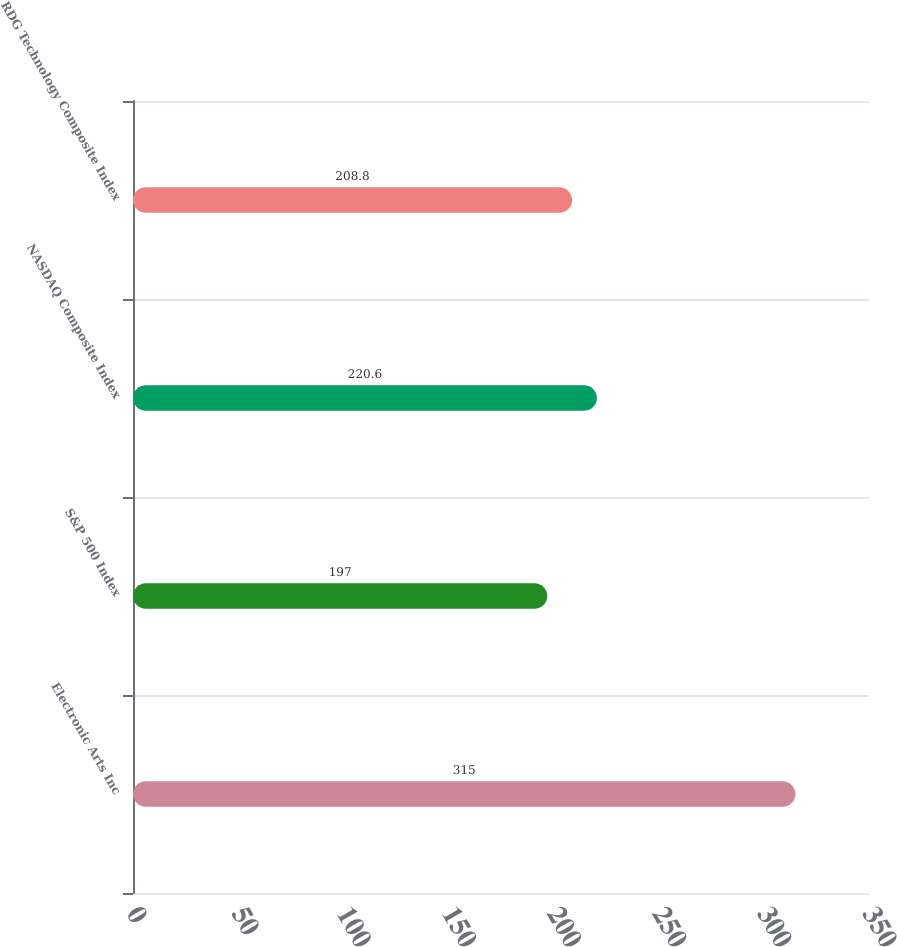<chart> <loc_0><loc_0><loc_500><loc_500><bar_chart><fcel>Electronic Arts Inc<fcel>S&P 500 Index<fcel>NASDAQ Composite Index<fcel>RDG Technology Composite Index<nl><fcel>315<fcel>197<fcel>220.6<fcel>208.8<nl></chart> 